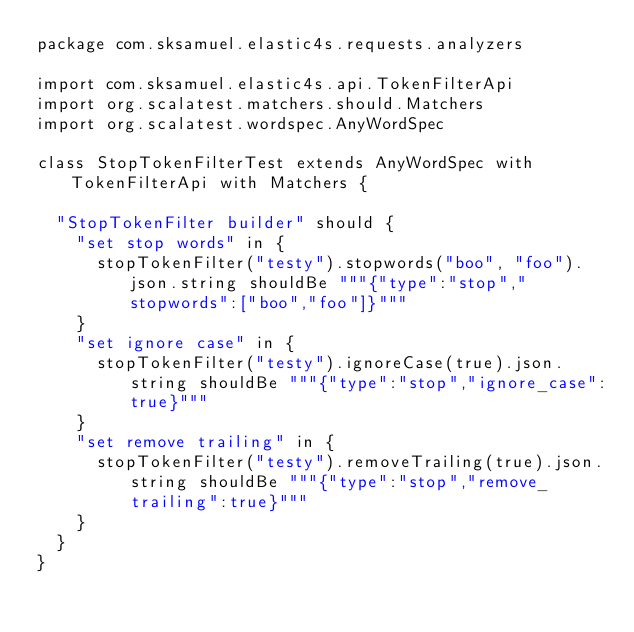Convert code to text. <code><loc_0><loc_0><loc_500><loc_500><_Scala_>package com.sksamuel.elastic4s.requests.analyzers

import com.sksamuel.elastic4s.api.TokenFilterApi
import org.scalatest.matchers.should.Matchers
import org.scalatest.wordspec.AnyWordSpec

class StopTokenFilterTest extends AnyWordSpec with TokenFilterApi with Matchers {

  "StopTokenFilter builder" should {
    "set stop words" in {
      stopTokenFilter("testy").stopwords("boo", "foo").json.string shouldBe """{"type":"stop","stopwords":["boo","foo"]}"""
    }
    "set ignore case" in {
      stopTokenFilter("testy").ignoreCase(true).json.string shouldBe """{"type":"stop","ignore_case":true}"""
    }
    "set remove trailing" in {
      stopTokenFilter("testy").removeTrailing(true).json.string shouldBe """{"type":"stop","remove_trailing":true}"""
    }
  }
}
</code> 